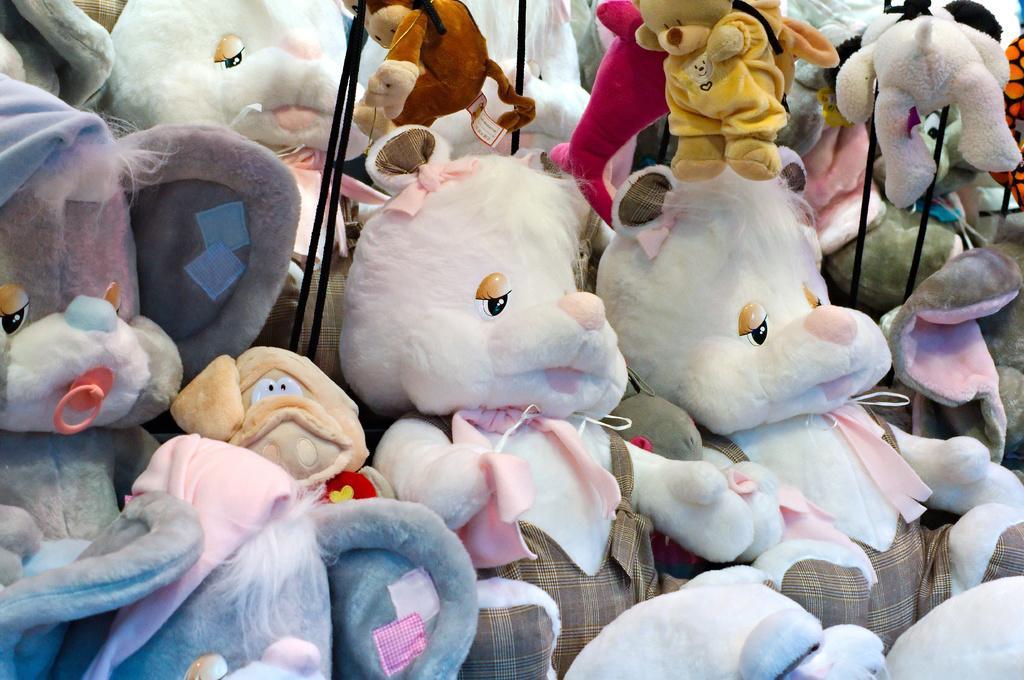How would you summarize this image in a sentence or two? In this image I see number of soft toys which are of white, grey, cream, orange, pink and yellow in color and I see clothes on them and I see the black color ropes. 